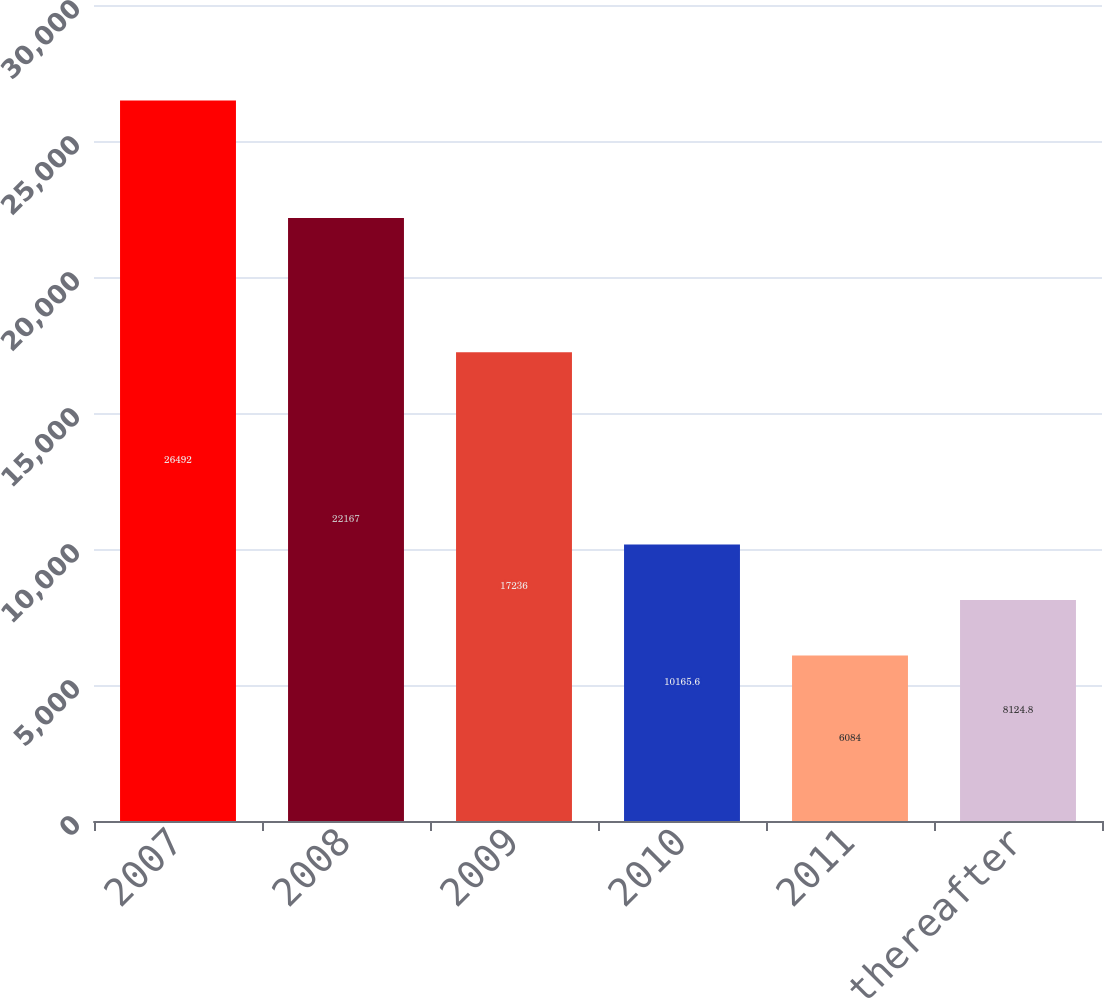<chart> <loc_0><loc_0><loc_500><loc_500><bar_chart><fcel>2007<fcel>2008<fcel>2009<fcel>2010<fcel>2011<fcel>2012 and thereafter<nl><fcel>26492<fcel>22167<fcel>17236<fcel>10165.6<fcel>6084<fcel>8124.8<nl></chart> 